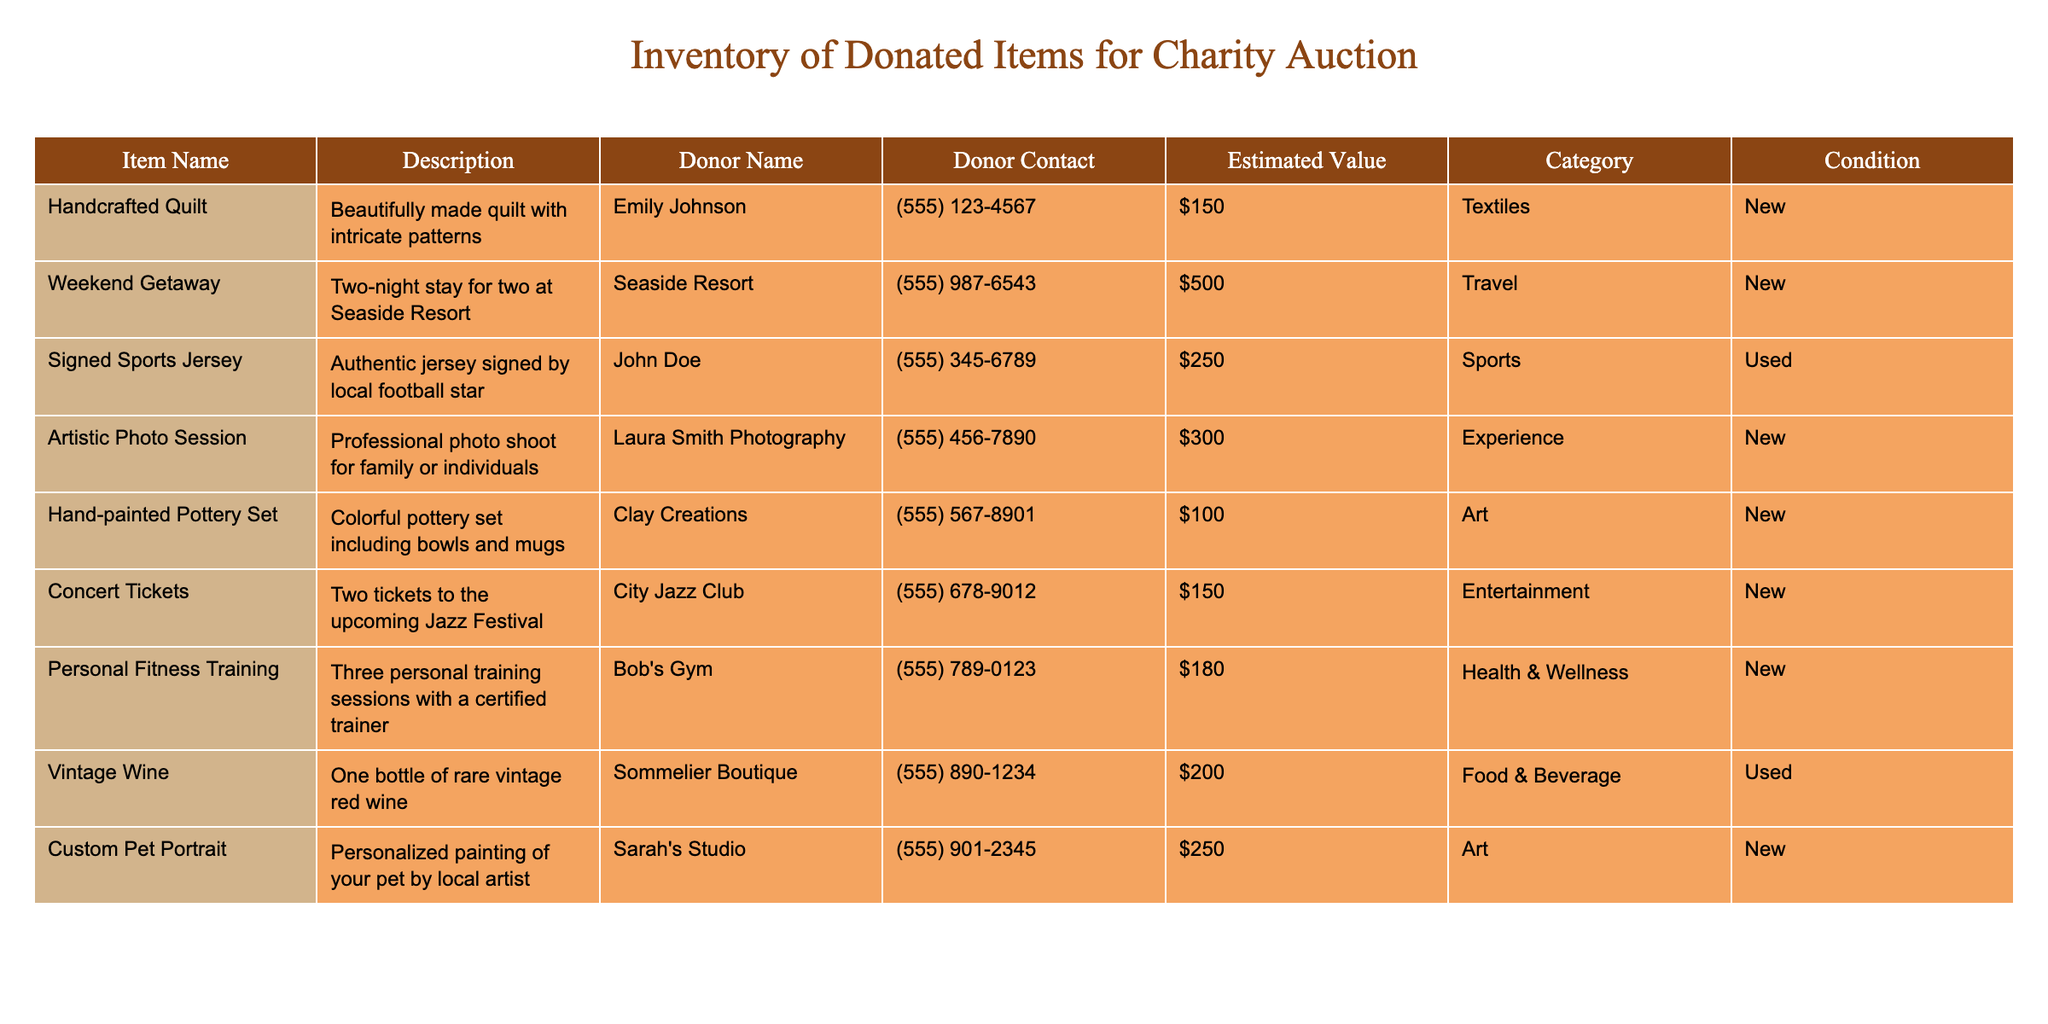What is the estimated value of the Handcrafted Quilt? The estimated value can be found in the 'Estimated Value' column for the Handcrafted Quilt row, which lists it as $150.
Answer: $150 Who donated the Weekend Getaway? The donor's name for the Weekend Getaway can be found in the 'Donor Name' column for that row, which is Seaside Resort.
Answer: Seaside Resort How many items in the inventory are categorized as 'Art'? There are two items categorized as 'Art': the Hand-painted Pottery Set and the Custom Pet Portrait. Therefore, the count is 2.
Answer: 2 Is the Signed Sports Jersey in new condition? By checking the 'Condition' column for the Signed Sports Jersey, it says 'Used', indicating that it is not in new condition.
Answer: No What is the total estimated value of all the items listed in the inventory? To find the total value, add all estimated values: 150 + 500 + 250 + 300 + 100 + 150 + 180 + 200 + 250 = 1880.
Answer: $1880 Are there any items in the inventory that belong to the 'Health & Wellness' category? Yes, the Personal Fitness Training entry is listed under the 'Health & Wellness' category, confirming the existence of such an item.
Answer: Yes Which item has the highest estimated value and what is that value? By reviewing the 'Estimated Value' column, the item with the highest value is the Weekend Getaway at $500.
Answer: $500 What percentage of the total inventory value comes from brand new items? Of the total estimated values, the new items are Handcrafted Quilt, Weekend Getaway, Artistic Photo Session, Hand-painted Pottery Set, Concert Tickets, Personal Fitness Training, and Custom Pet Portrait. Their sum is 150 + 500 + 300 + 100 + 150 + 180 + 250 = 1630. Therefore, the percentage is (1630/1880) * 100 ≈ 86.70%.
Answer: 86.70% Which donor provided the item with the lowest estimated value? The item with the lowest estimated value is the Hand-painted Pottery Set at $100, which was donated by Clay Creations; thus, Clay Creations is the correct answer.
Answer: Clay Creations 